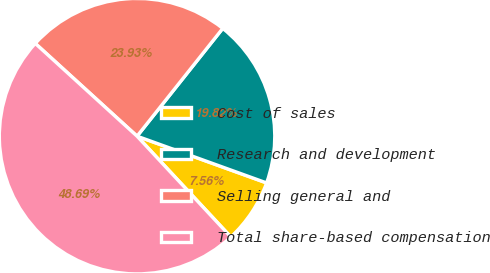Convert chart. <chart><loc_0><loc_0><loc_500><loc_500><pie_chart><fcel>Cost of sales<fcel>Research and development<fcel>Selling general and<fcel>Total share-based compensation<nl><fcel>7.56%<fcel>19.82%<fcel>23.93%<fcel>48.69%<nl></chart> 